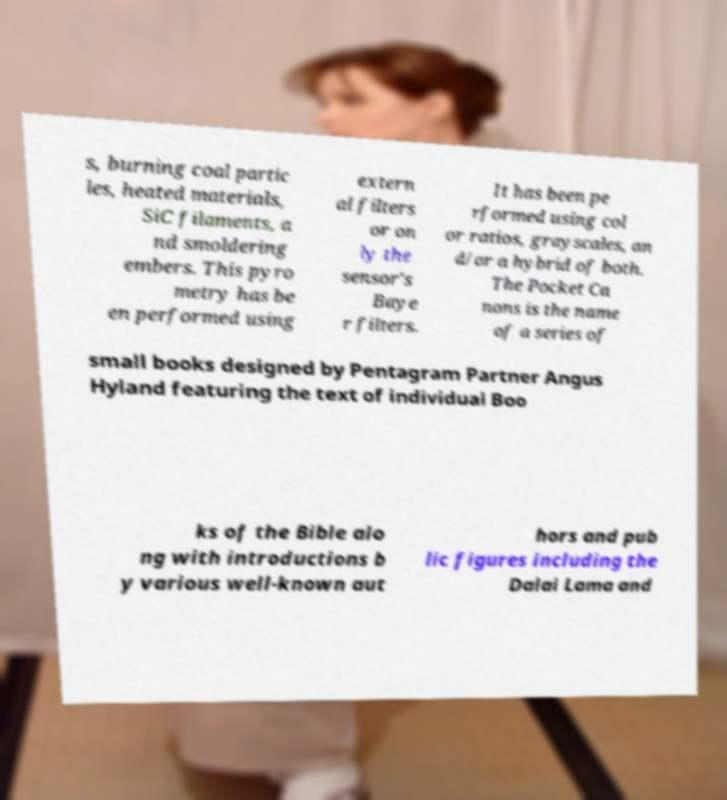What messages or text are displayed in this image? I need them in a readable, typed format. s, burning coal partic les, heated materials, SiC filaments, a nd smoldering embers. This pyro metry has be en performed using extern al filters or on ly the sensor's Baye r filters. It has been pe rformed using col or ratios, grayscales, an d/or a hybrid of both. The Pocket Ca nons is the name of a series of small books designed by Pentagram Partner Angus Hyland featuring the text of individual Boo ks of the Bible alo ng with introductions b y various well-known aut hors and pub lic figures including the Dalai Lama and 